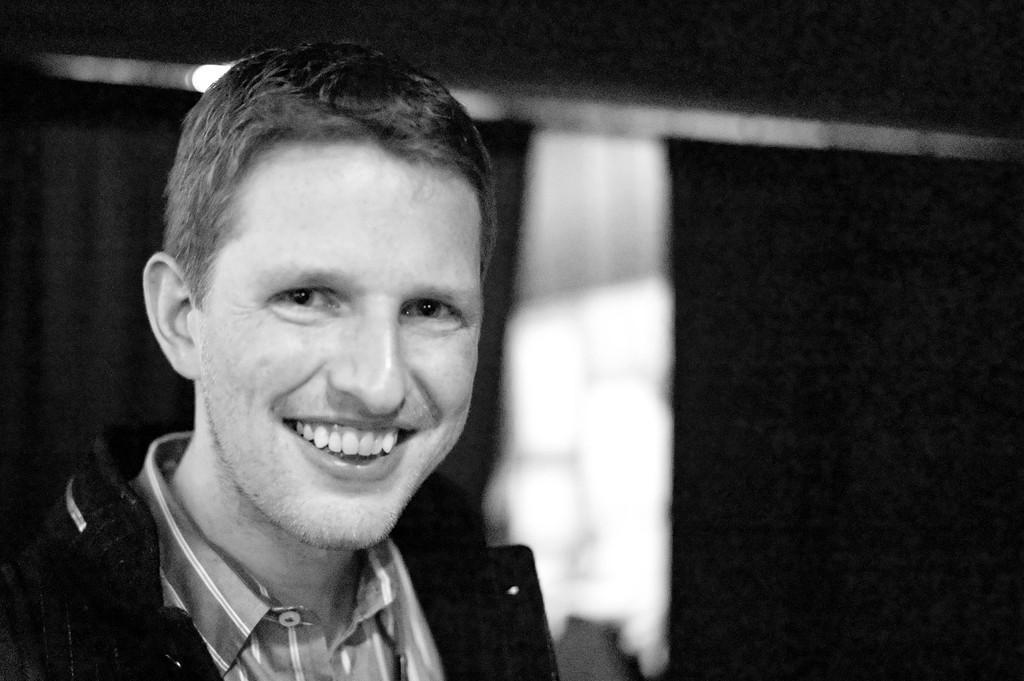Could you give a brief overview of what you see in this image? In the picture I can see a man is smiling. The background of the image is blurred. This picture is black and white in color. 